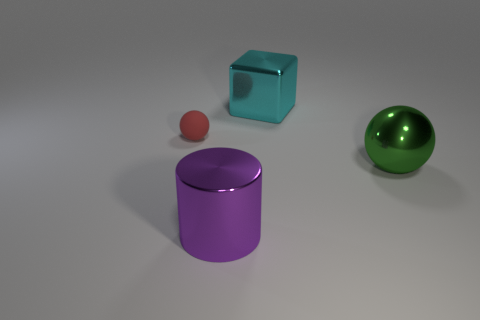Add 4 big cyan blocks. How many objects exist? 8 Subtract all cubes. How many objects are left? 3 Subtract 1 purple cylinders. How many objects are left? 3 Subtract all large cyan rubber blocks. Subtract all green balls. How many objects are left? 3 Add 3 matte spheres. How many matte spheres are left? 4 Add 1 cyan shiny cylinders. How many cyan shiny cylinders exist? 1 